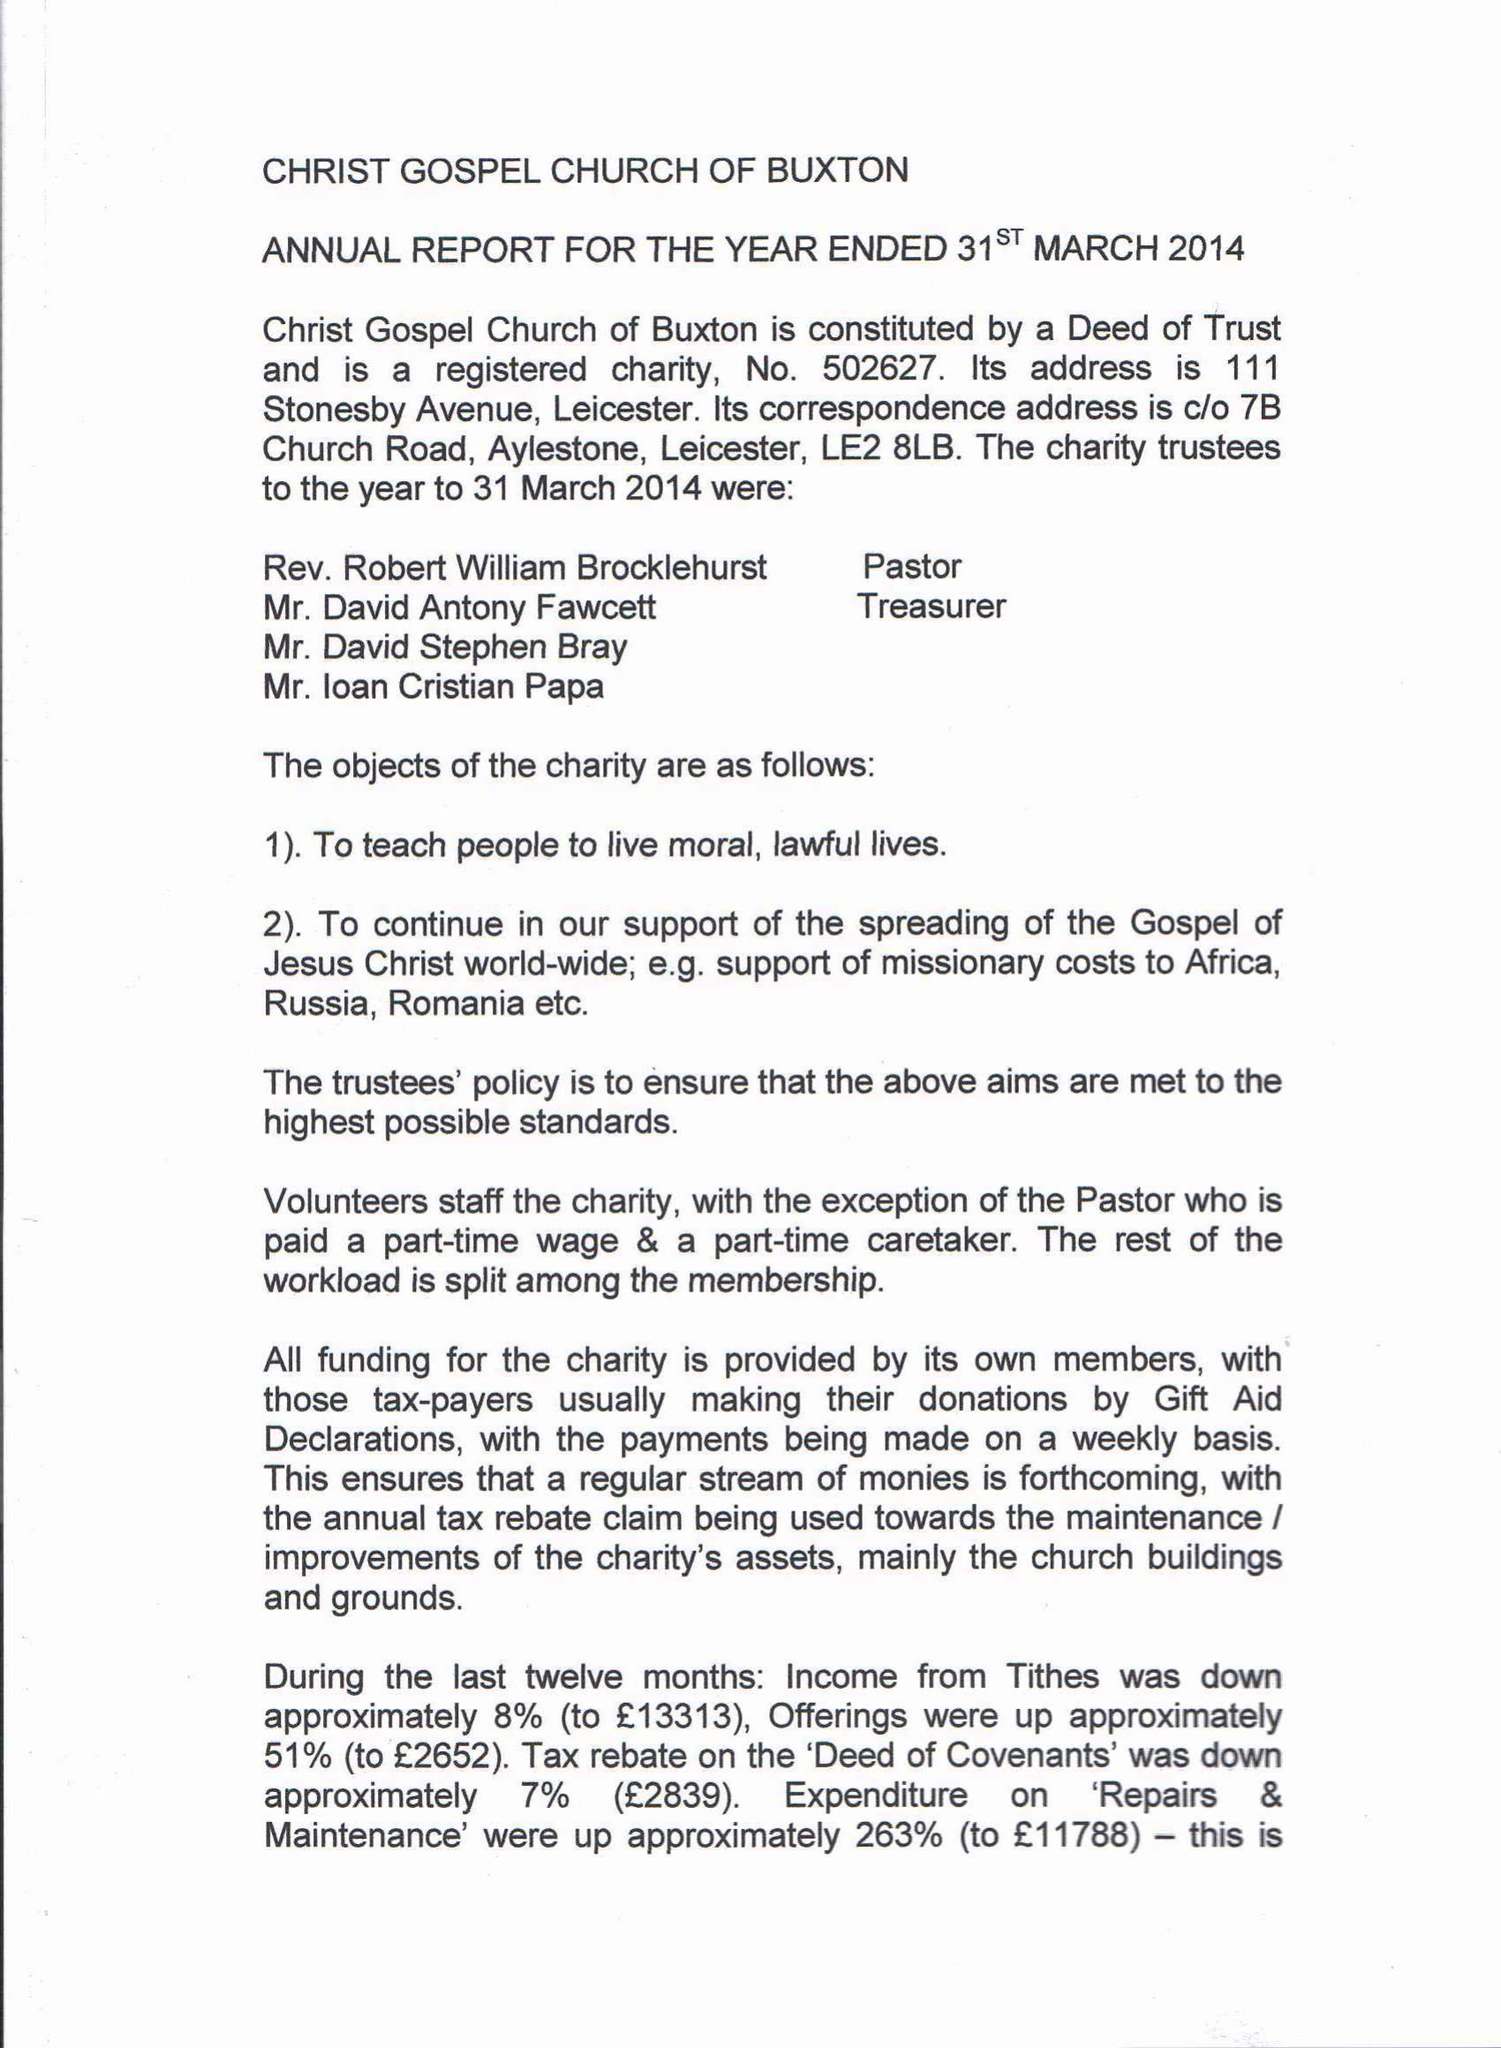What is the value for the address__post_town?
Answer the question using a single word or phrase. LEICESTER 